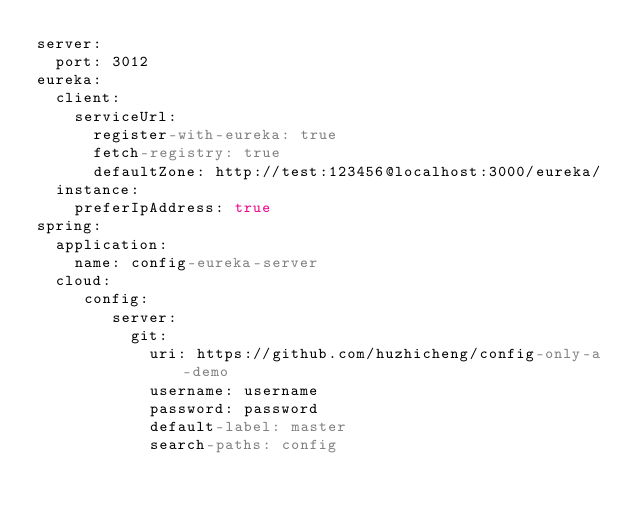<code> <loc_0><loc_0><loc_500><loc_500><_YAML_>server:
  port: 3012
eureka:
  client:
    serviceUrl:
      register-with-eureka: true
      fetch-registry: true
      defaultZone: http://test:123456@localhost:3000/eureka/
  instance:
    preferIpAddress: true
spring:
  application:
    name: config-eureka-server
  cloud:
     config:
        server:
          git:
            uri: https://github.com/huzhicheng/config-only-a-demo
            username: username
            password: password
            default-label: master
            search-paths: config</code> 